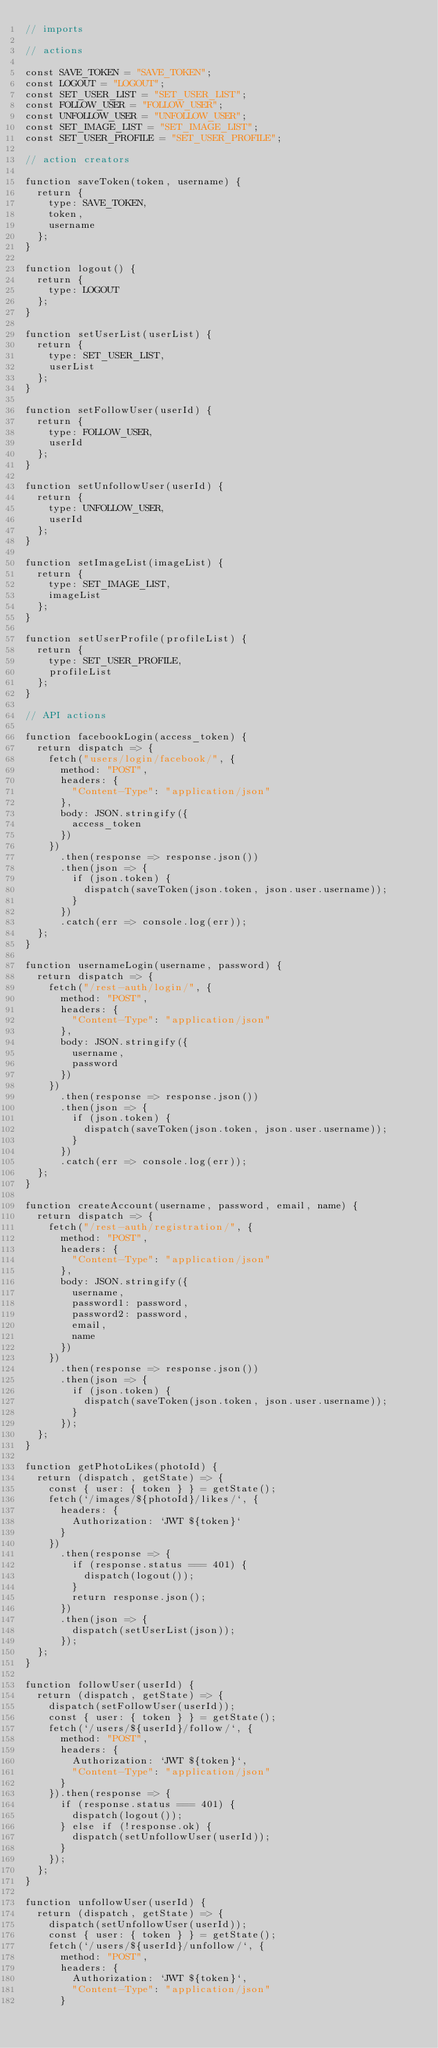Convert code to text. <code><loc_0><loc_0><loc_500><loc_500><_JavaScript_>// imports

// actions

const SAVE_TOKEN = "SAVE_TOKEN";
const LOGOUT = "LOGOUT";
const SET_USER_LIST = "SET_USER_LIST";
const FOLLOW_USER = "FOLLOW_USER";
const UNFOLLOW_USER = "UNFOLLOW_USER";
const SET_IMAGE_LIST = "SET_IMAGE_LIST";
const SET_USER_PROFILE = "SET_USER_PROFILE";

// action creators

function saveToken(token, username) {
  return {
    type: SAVE_TOKEN,
    token,
    username
  };
}

function logout() {
  return {
    type: LOGOUT
  };
}

function setUserList(userList) {
  return {
    type: SET_USER_LIST,
    userList
  };
}

function setFollowUser(userId) {
  return {
    type: FOLLOW_USER,
    userId
  };
}

function setUnfollowUser(userId) {
  return {
    type: UNFOLLOW_USER,
    userId
  };
}

function setImageList(imageList) {
  return {
    type: SET_IMAGE_LIST,
    imageList
  };
}

function setUserProfile(profileList) {
  return {
    type: SET_USER_PROFILE,
    profileList
  };
}

// API actions

function facebookLogin(access_token) {
  return dispatch => {
    fetch("users/login/facebook/", {
      method: "POST",
      headers: {
        "Content-Type": "application/json"
      },
      body: JSON.stringify({
        access_token
      })
    })
      .then(response => response.json())
      .then(json => {
        if (json.token) {
          dispatch(saveToken(json.token, json.user.username));
        }
      })
      .catch(err => console.log(err));
  };
}

function usernameLogin(username, password) {
  return dispatch => {
    fetch("/rest-auth/login/", {
      method: "POST",
      headers: {
        "Content-Type": "application/json"
      },
      body: JSON.stringify({
        username,
        password
      })
    })
      .then(response => response.json())
      .then(json => {
        if (json.token) {
          dispatch(saveToken(json.token, json.user.username));
        }
      })
      .catch(err => console.log(err));
  };
}

function createAccount(username, password, email, name) {
  return dispatch => {
    fetch("/rest-auth/registration/", {
      method: "POST",
      headers: {
        "Content-Type": "application/json"
      },
      body: JSON.stringify({
        username,
        password1: password,
        password2: password,
        email,
        name
      })
    })
      .then(response => response.json())
      .then(json => {
        if (json.token) {
          dispatch(saveToken(json.token, json.user.username));
        }
      });
  };
}

function getPhotoLikes(photoId) {
  return (dispatch, getState) => {
    const { user: { token } } = getState();
    fetch(`/images/${photoId}/likes/`, {
      headers: {
        Authorization: `JWT ${token}`
      }
    })
      .then(response => {
        if (response.status === 401) {
          dispatch(logout());
        }
        return response.json();
      })
      .then(json => {
        dispatch(setUserList(json));
      });
  };
}

function followUser(userId) {
  return (dispatch, getState) => {
    dispatch(setFollowUser(userId));
    const { user: { token } } = getState();
    fetch(`/users/${userId}/follow/`, {
      method: "POST",
      headers: {
        Authorization: `JWT ${token}`,
        "Content-Type": "application/json"
      }
    }).then(response => {
      if (response.status === 401) {
        dispatch(logout());
      } else if (!response.ok) {
        dispatch(setUnfollowUser(userId));
      }
    });
  };
}

function unfollowUser(userId) {
  return (dispatch, getState) => {
    dispatch(setUnfollowUser(userId));
    const { user: { token } } = getState();
    fetch(`/users/${userId}/unfollow/`, {
      method: "POST",
      headers: {
        Authorization: `JWT ${token}`,
        "Content-Type": "application/json"
      }</code> 